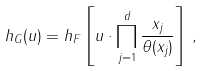<formula> <loc_0><loc_0><loc_500><loc_500>h _ { G } ( u ) = h _ { F } \left [ u \cdot \prod _ { j = 1 } ^ { d } \frac { x _ { j } } { \theta ( x _ { j } ) } \right ] \, ,</formula> 